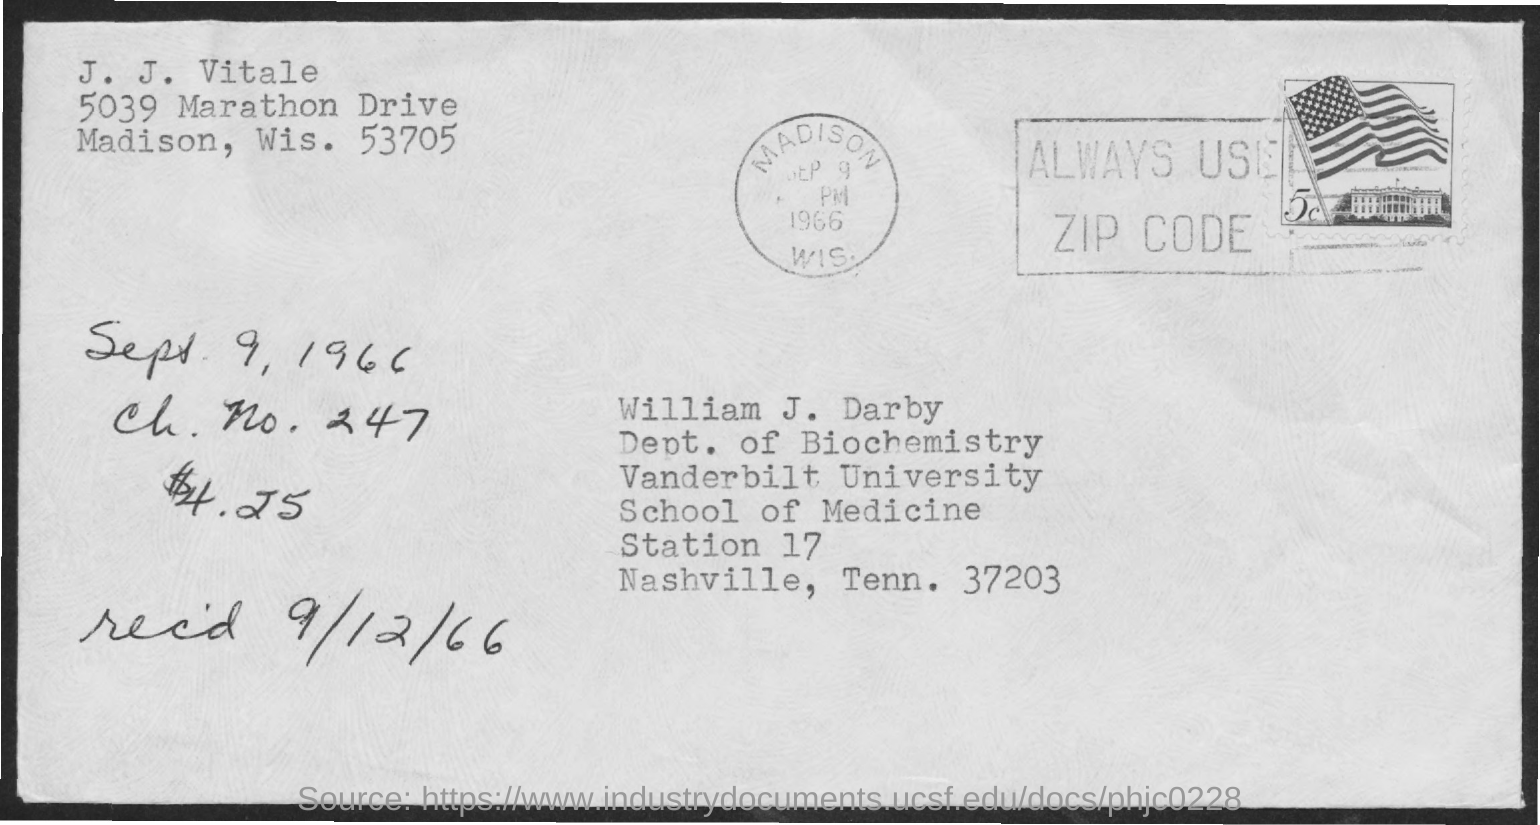Who's from the vanderbilt university as given in the address?
Provide a short and direct response. William J. Darby. What is the received date mentioned in the postal card?
Offer a terse response. 9/12/66. What is the ch. no. given?
Your answer should be compact. 247. 